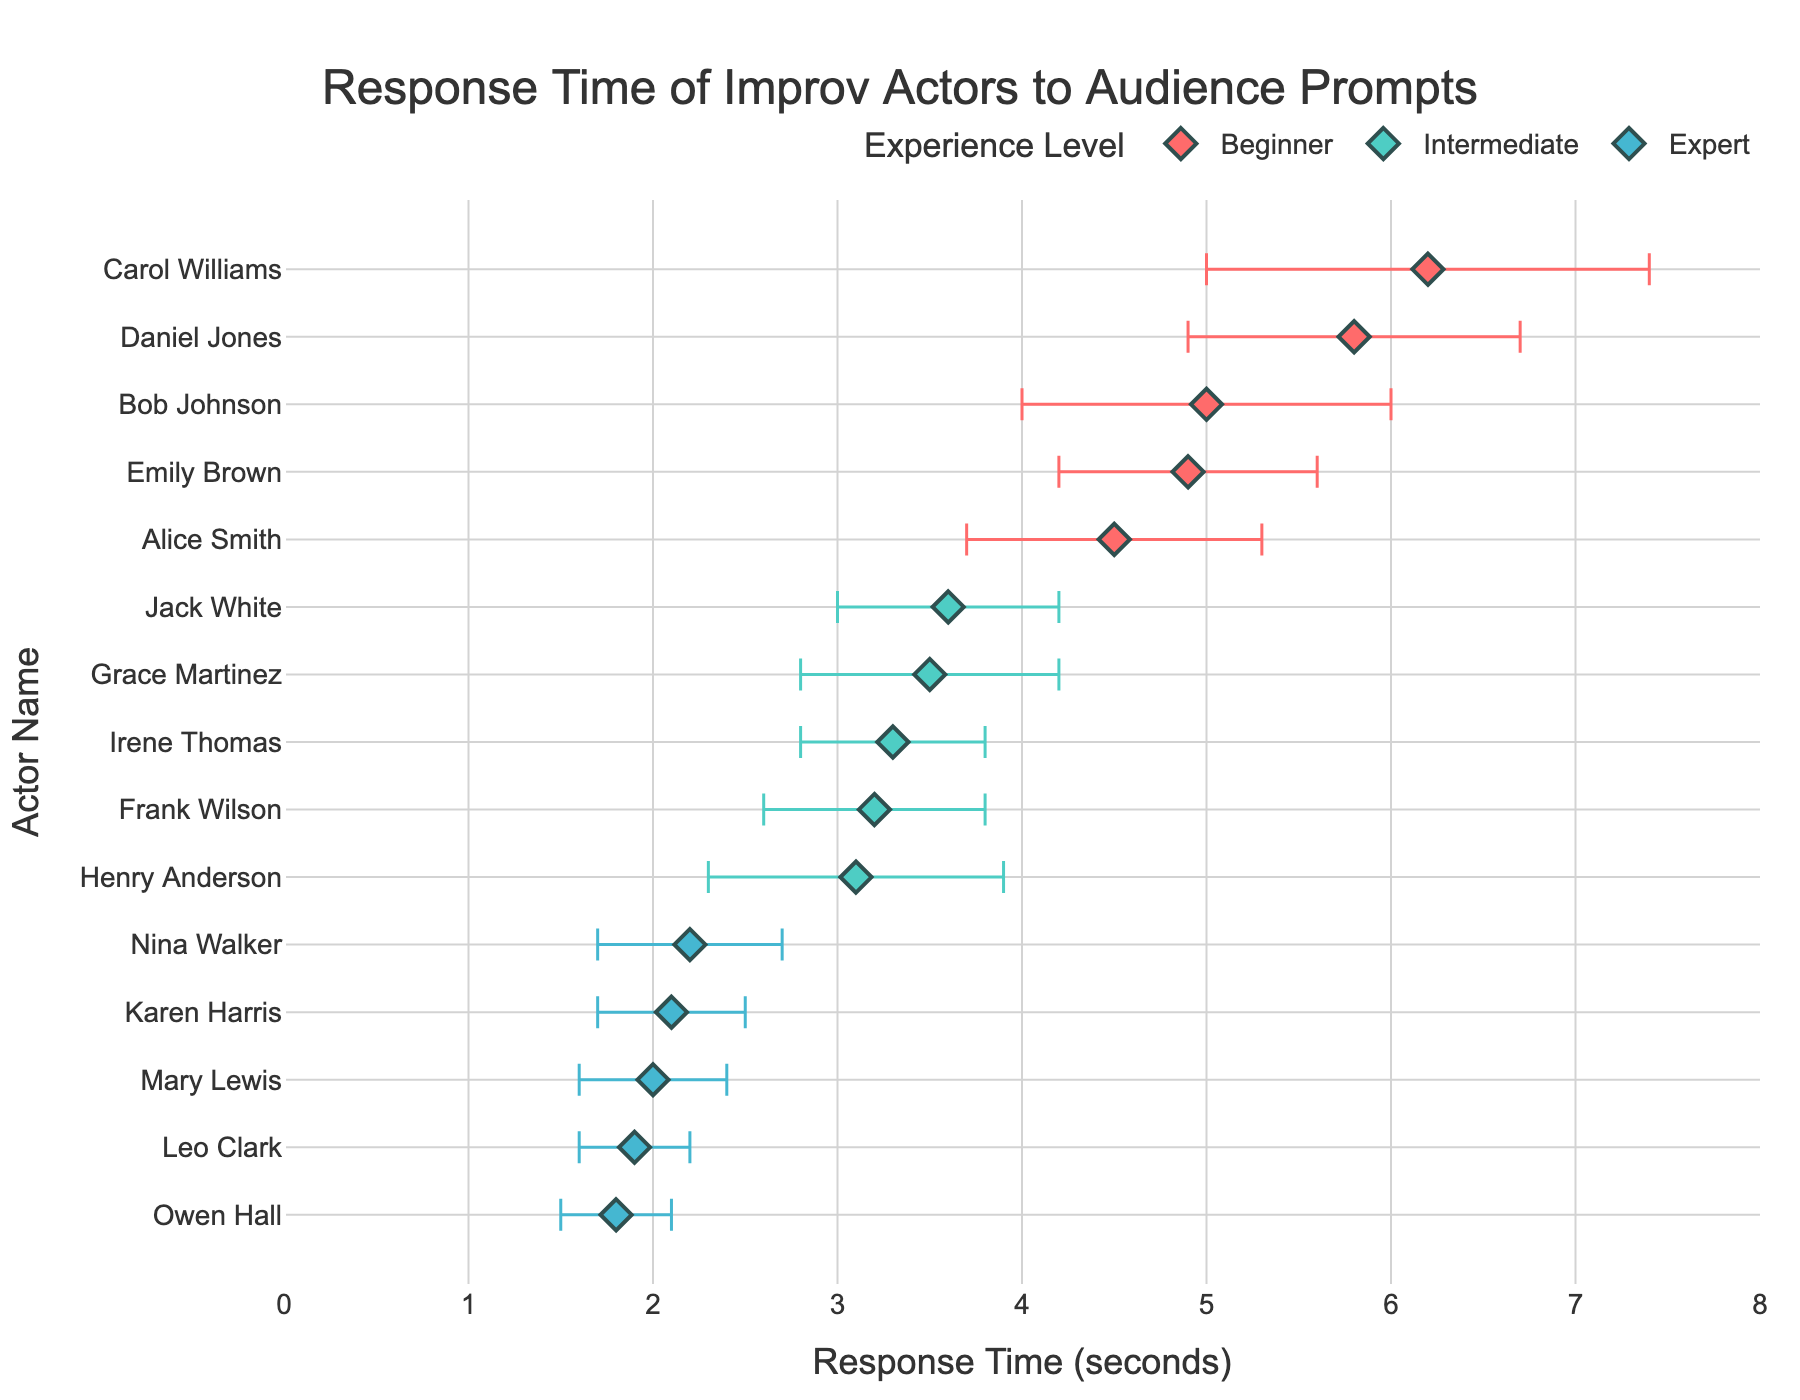What's the title of the plot? The title is usually displayed at the top of the plot. In this figure, the title is centrally aligned at the top.
Answer: Response Time of Improv Actors to Audience Prompts How is the x-axis labeled? The x-axis label can be found below the horizontal axis on the plot. In this figure, it states what the x-axis represents.
Answer: Response Time (seconds) Which experience level has the actor with the fastest response time? To determine the fastest response time, locate the point closest to the origin (leftmost) within each experience level and compare them.
Answer: Expert What are the range values on the x-axis? The range values on the x-axis can be seen at the furthest left and right points of the axis. In this plot, they are defined to show the extent of the data.
Answer: 0 to 8 How many different experience levels are represented in the plot? By examining the legend or the different colors representing each group, we can count the distinct experience levels.
Answer: 3 What is the average response time for the Beginner group? To find the average, sum all the response times of the Beginner group and divide by the number of actors in that group. Calculation: (4.5 + 5.0 + 6.2 + 5.8 + 4.9) / 5 = 26.4 / 5
Answer: 5.28 seconds Which experience level has the highest variability in response times? The error bars indicate variability. The longest error bars suggest the highest variability. By comparing the size of error bars across experience levels, we find the answer.
Answer: Beginner How does the response time of Frank Wilson compare to that of Karen Harris? Locate the response times of Frank Wilson (Intermediate) and Karen Harris (Expert) in the plot and compare their values.
Answer: Frank Wilson is slower Among the experts, who has the largest error bar? By examining the error bars within the Expert group, identify the one with the greatest length.
Answer: Nina Walker Which actor has the slowest overall response time, and what is that time? Identify the actor with the point furthest to the right on the x-axis, as this indicates the slowest response.
Answer: Carol Williams, 6.2 seconds 